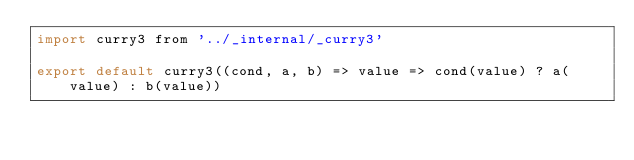Convert code to text. <code><loc_0><loc_0><loc_500><loc_500><_JavaScript_>import curry3 from '../_internal/_curry3'

export default curry3((cond, a, b) => value => cond(value) ? a(value) : b(value))
</code> 